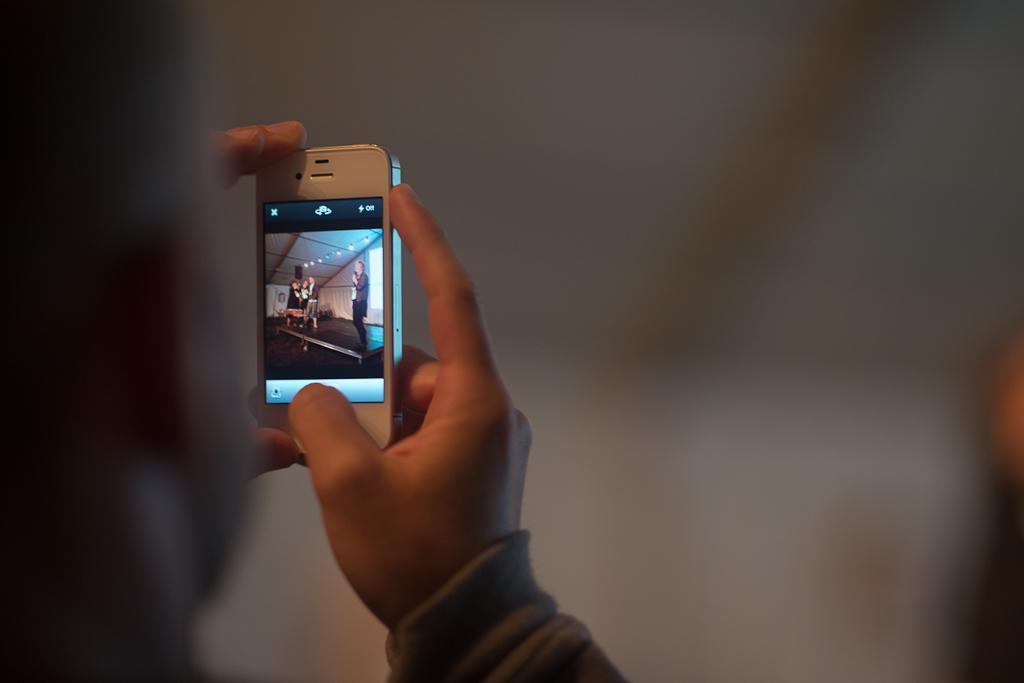Can you describe this image briefly? In this image there is a person holding a mobile phone in his hand. 